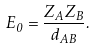Convert formula to latex. <formula><loc_0><loc_0><loc_500><loc_500>E _ { 0 } = \frac { Z _ { A } Z _ { B } } { d _ { A B } } .</formula> 